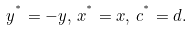Convert formula to latex. <formula><loc_0><loc_0><loc_500><loc_500>y ^ { ^ { * } } = - y , \, x ^ { ^ { * } } = x , \, c ^ { ^ { * } } = d .</formula> 